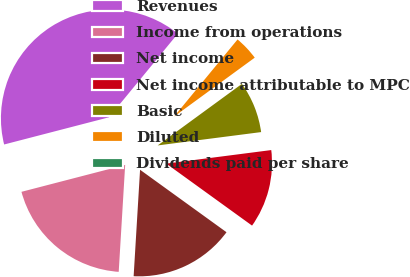<chart> <loc_0><loc_0><loc_500><loc_500><pie_chart><fcel>Revenues<fcel>Income from operations<fcel>Net income<fcel>Net income attributable to MPC<fcel>Basic<fcel>Diluted<fcel>Dividends paid per share<nl><fcel>40.0%<fcel>20.0%<fcel>16.0%<fcel>12.0%<fcel>8.0%<fcel>4.0%<fcel>0.0%<nl></chart> 